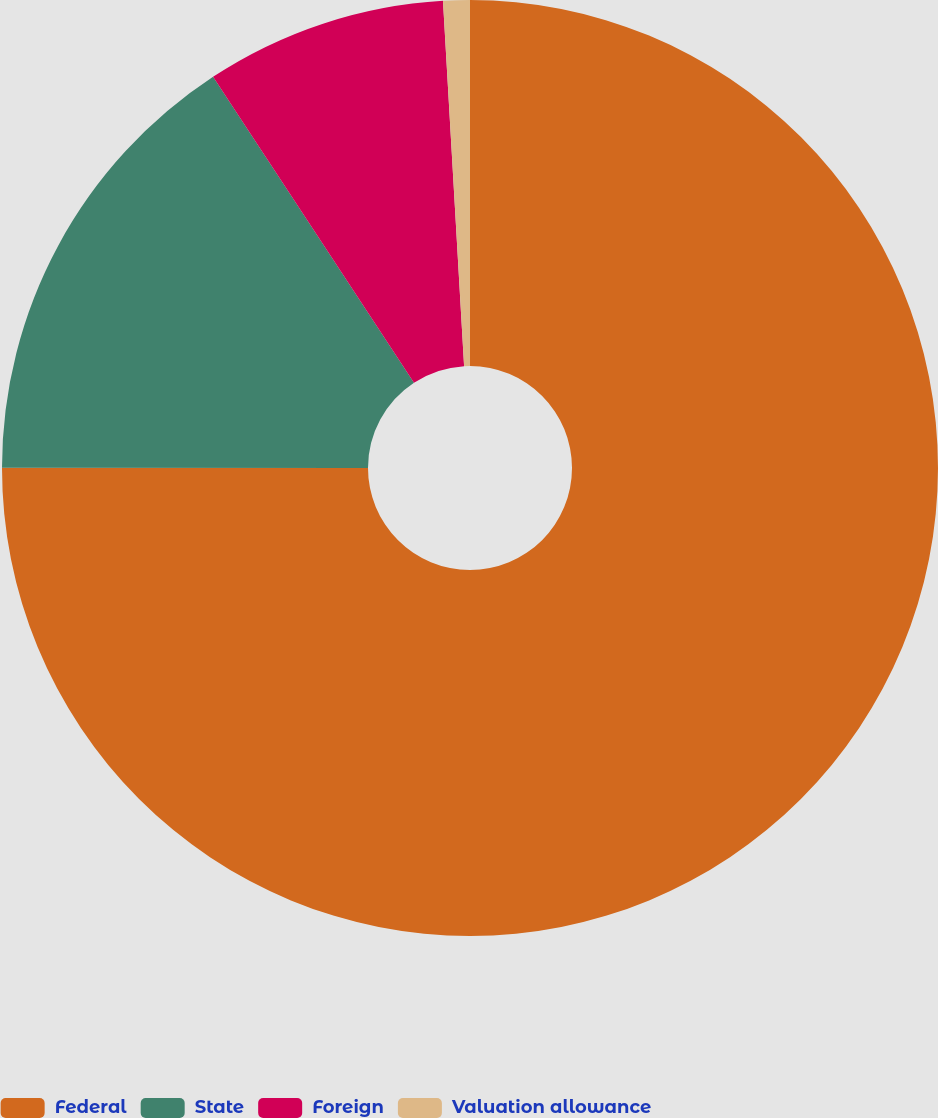Convert chart. <chart><loc_0><loc_0><loc_500><loc_500><pie_chart><fcel>Federal<fcel>State<fcel>Foreign<fcel>Valuation allowance<nl><fcel>75.01%<fcel>15.74%<fcel>8.33%<fcel>0.92%<nl></chart> 